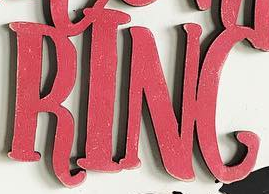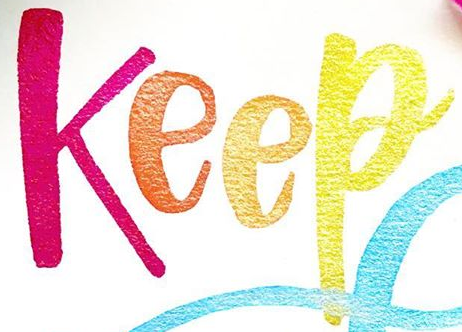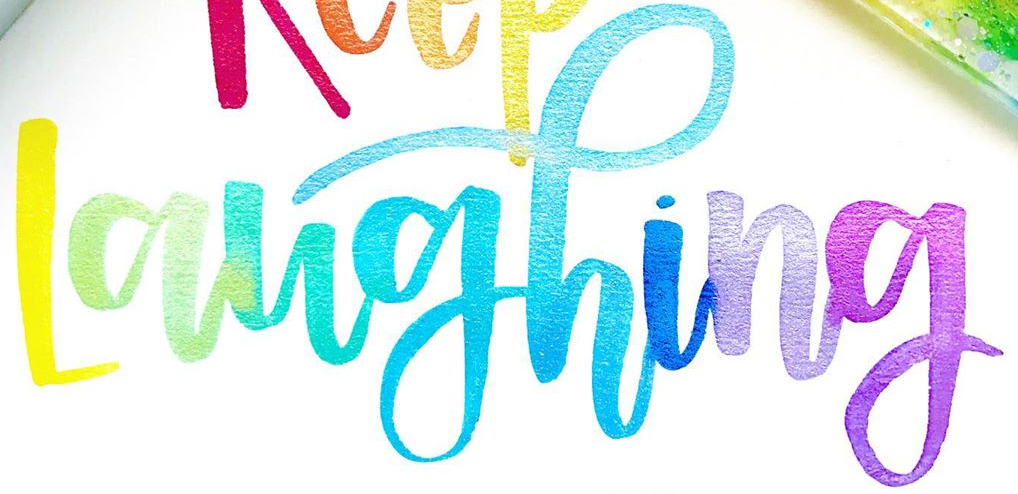What words are shown in these images in order, separated by a semicolon? RING; Keep; Laughing 